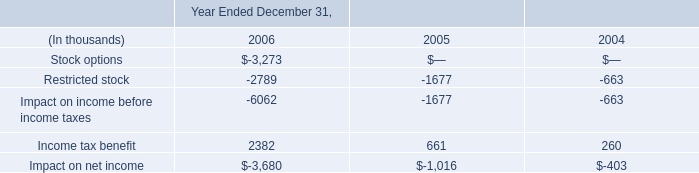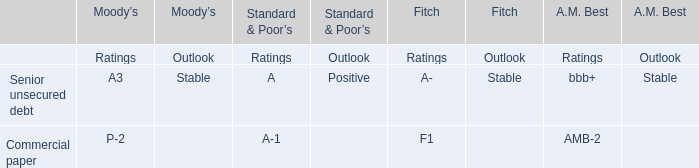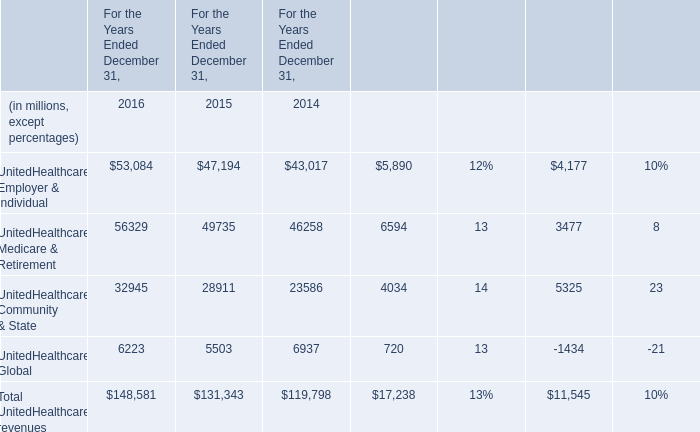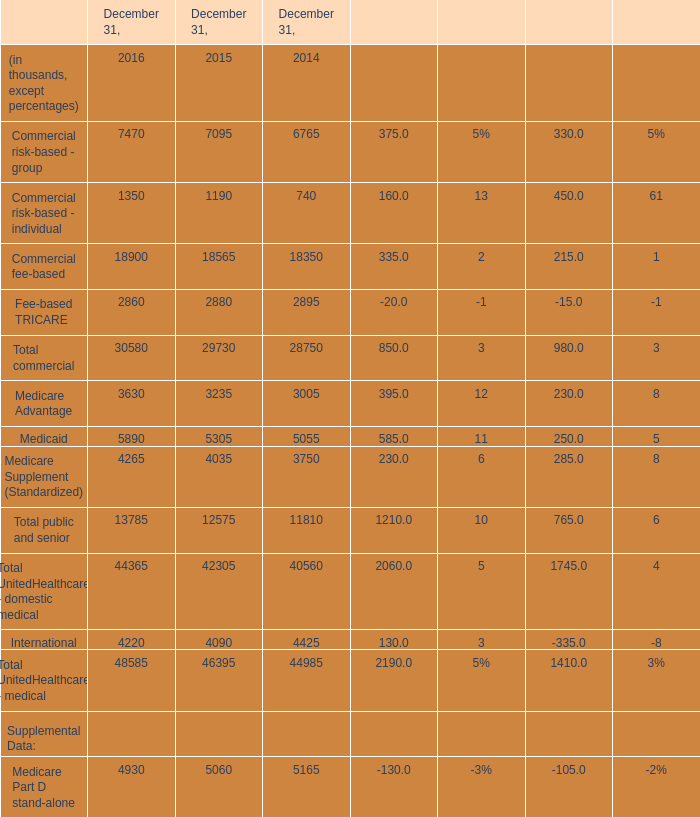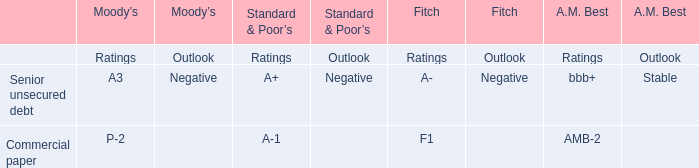Which United Healthcare revenues has the second largest number in 2016? 
Answer: United Healthcare Employer & Individual. 